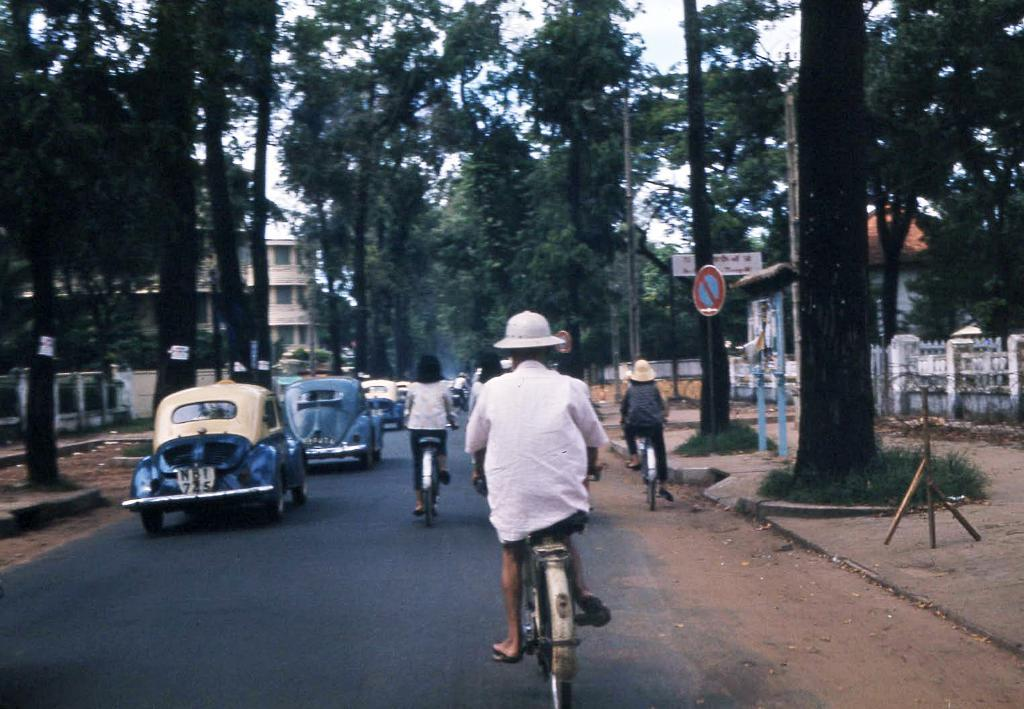What type of vegetation can be seen in the image? There are trees in the image. What structures are visible in the image? There are buildings in the image. What mode of transportation can be seen in the image? There are cars in the image. What activity are some people engaged in within the image? There are people riding bicycles in the image. What is the name of the self that is riding a bicycle in the image? There is no self present in the image, as the term "self" refers to an individual's identity or consciousness, which cannot be seen in a photograph. 